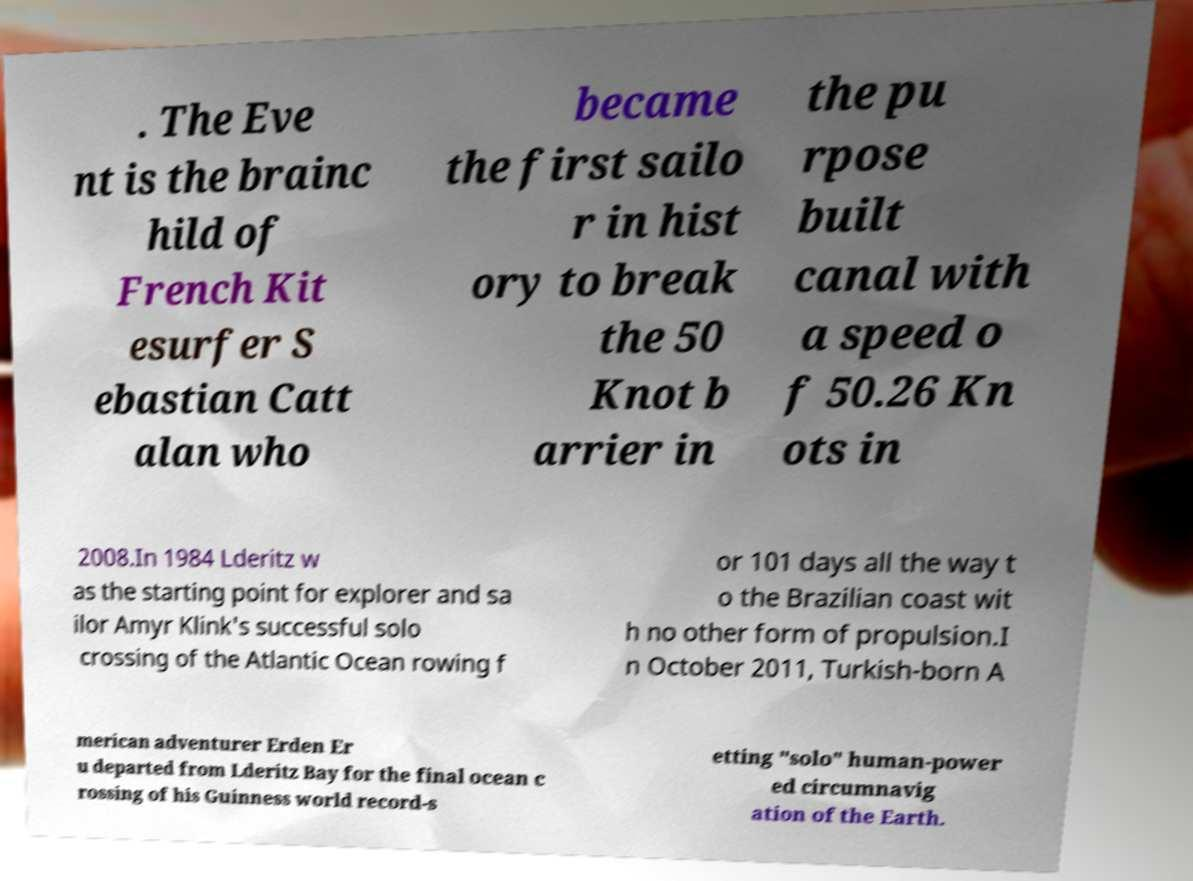Please read and relay the text visible in this image. What does it say? . The Eve nt is the brainc hild of French Kit esurfer S ebastian Catt alan who became the first sailo r in hist ory to break the 50 Knot b arrier in the pu rpose built canal with a speed o f 50.26 Kn ots in 2008.In 1984 Lderitz w as the starting point for explorer and sa ilor Amyr Klink's successful solo crossing of the Atlantic Ocean rowing f or 101 days all the way t o the Brazilian coast wit h no other form of propulsion.I n October 2011, Turkish-born A merican adventurer Erden Er u departed from Lderitz Bay for the final ocean c rossing of his Guinness world record-s etting "solo" human-power ed circumnavig ation of the Earth. 